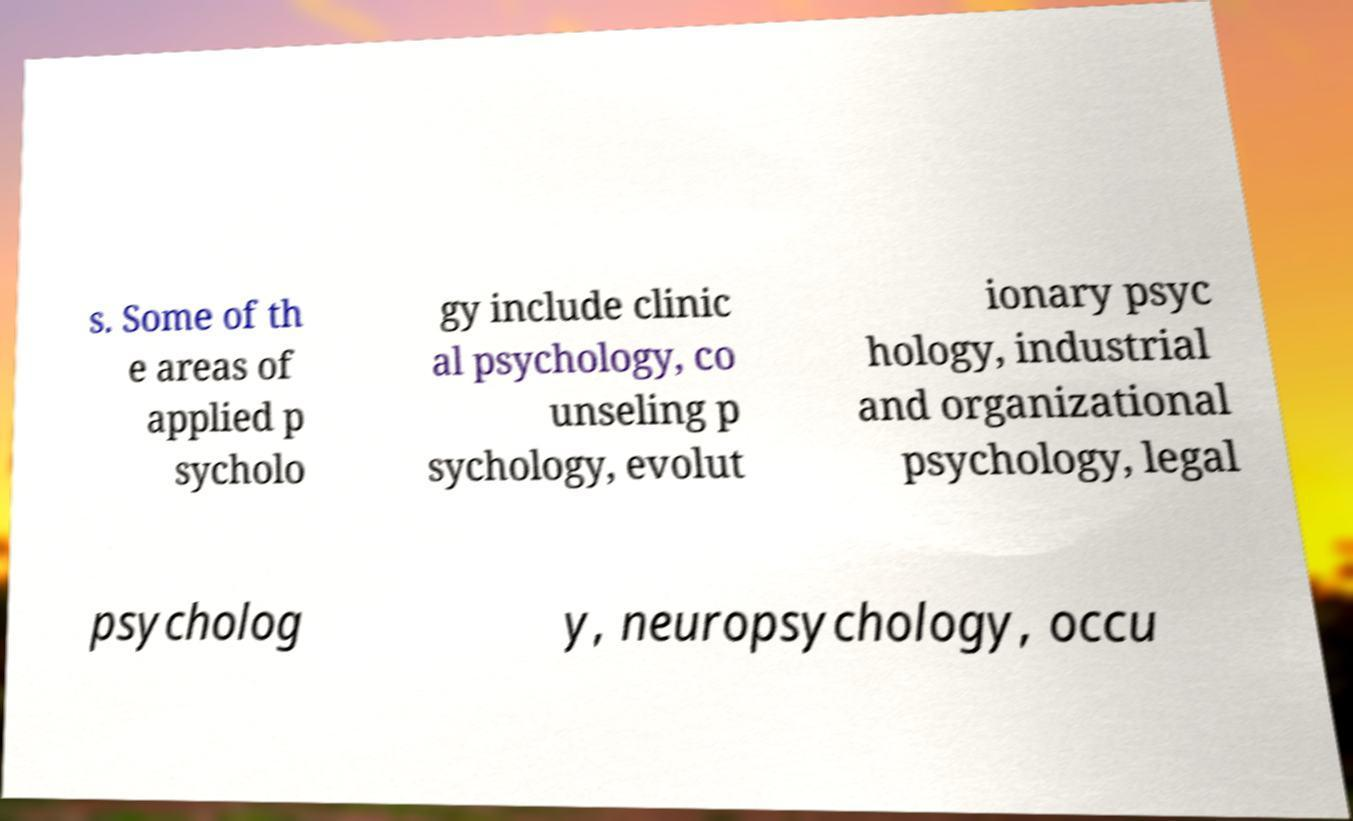I need the written content from this picture converted into text. Can you do that? s. Some of th e areas of applied p sycholo gy include clinic al psychology, co unseling p sychology, evolut ionary psyc hology, industrial and organizational psychology, legal psycholog y, neuropsychology, occu 